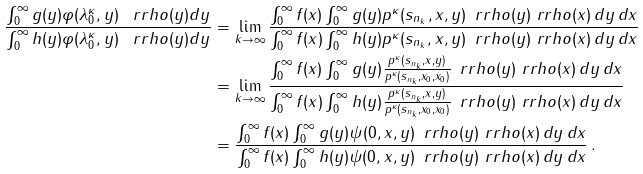Convert formula to latex. <formula><loc_0><loc_0><loc_500><loc_500>\frac { \int _ { 0 } ^ { \infty } g ( y ) \varphi ( \lambda _ { 0 } ^ { \kappa } , y ) \, \ r r h o ( y ) d y } { \int _ { 0 } ^ { \infty } h ( y ) \varphi ( \lambda _ { 0 } ^ { \kappa } , y ) \, \ r r h o ( y ) d y } & = \lim _ { k \rightarrow \infty } \frac { \int _ { 0 } ^ { \infty } f ( x ) \int _ { 0 } ^ { \infty } g ( y ) p ^ { \kappa } ( s _ { n _ { k } } , x , y ) \, \ r r h o ( y ) \ r r h o ( x ) \, d y \, d x } { \int _ { 0 } ^ { \infty } f ( x ) \int _ { 0 } ^ { \infty } h ( y ) p ^ { \kappa } ( s _ { n _ { k } } , x , y ) \, \ r r h o ( y ) \ r r h o ( x ) \, d y \, d x } \\ & = \lim _ { k \rightarrow \infty } \frac { \int _ { 0 } ^ { \infty } f ( x ) \int _ { 0 } ^ { \infty } g ( y ) \frac { p ^ { \kappa } ( s _ { n _ { k } } , x , y ) } { p ^ { \kappa } ( s _ { n _ { k } } , x _ { 0 } , x _ { 0 } ) } \, \ r r h o ( y ) \ r r h o ( x ) \, d y \, d x } { \int _ { 0 } ^ { \infty } f ( x ) \int _ { 0 } ^ { \infty } h ( y ) \frac { p ^ { \kappa } ( s _ { n _ { k } } , x , y ) } { p ^ { \kappa } ( s _ { n _ { k } } , x _ { 0 } , x _ { 0 } ) } \, \ r r h o ( y ) \ r r h o ( x ) \, d y \, d x } \\ & = \frac { \int _ { 0 } ^ { \infty } f ( x ) \int _ { 0 } ^ { \infty } g ( y ) \psi ( 0 , x , y ) \, \ r r h o ( y ) \ r r h o ( x ) \, d y \, d x } { \int _ { 0 } ^ { \infty } f ( x ) \int _ { 0 } ^ { \infty } h ( y ) \psi ( 0 , x , y ) \, \ r r h o ( y ) \ r r h o ( x ) \, d y \, d x } \, .</formula> 